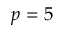<formula> <loc_0><loc_0><loc_500><loc_500>p = 5</formula> 